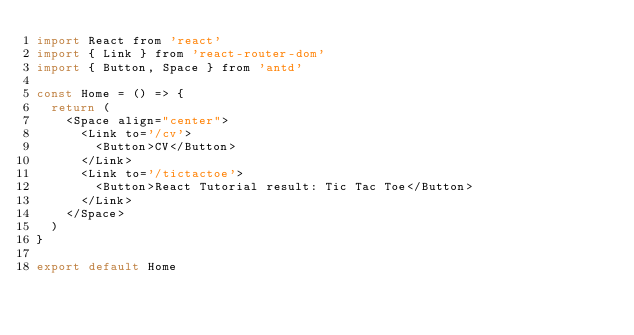Convert code to text. <code><loc_0><loc_0><loc_500><loc_500><_JavaScript_>import React from 'react'
import { Link } from 'react-router-dom'
import { Button, Space } from 'antd'

const Home = () => {
  return (
    <Space align="center">
      <Link to='/cv'>
        <Button>CV</Button>
      </Link>
      <Link to='/tictactoe'>
        <Button>React Tutorial result: Tic Tac Toe</Button>
      </Link>
    </Space>
  )
}

export default Home</code> 